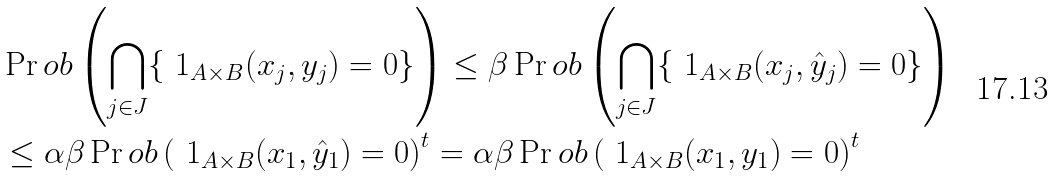Convert formula to latex. <formula><loc_0><loc_0><loc_500><loc_500>& \Pr o b \left ( \bigcap _ { j \in J } \{ \ 1 _ { A \times B } ( x _ { j } , y _ { j } ) = 0 \} \right ) \leq \beta \Pr o b \left ( \bigcap _ { j \in J } \{ \ 1 _ { A \times B } ( x _ { j } , \hat { y } _ { j } ) = 0 \} \right ) \\ & \leq \alpha \beta \Pr o b \left ( \ 1 _ { A \times B } ( x _ { 1 } , \hat { y } _ { 1 } ) = 0 \right ) ^ { t } = \alpha \beta \Pr o b \left ( \ 1 _ { A \times B } ( x _ { 1 } , y _ { 1 } ) = 0 \right ) ^ { t }</formula> 